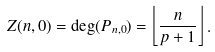Convert formula to latex. <formula><loc_0><loc_0><loc_500><loc_500>Z ( n , 0 ) = \deg ( P _ { n , 0 } ) = \left \lfloor \frac { n } { p + 1 } \right \rfloor .</formula> 